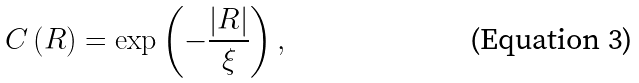<formula> <loc_0><loc_0><loc_500><loc_500>C \left ( R \right ) = \exp \left ( - \frac { \left | R \right | } { \xi } \right ) ,</formula> 